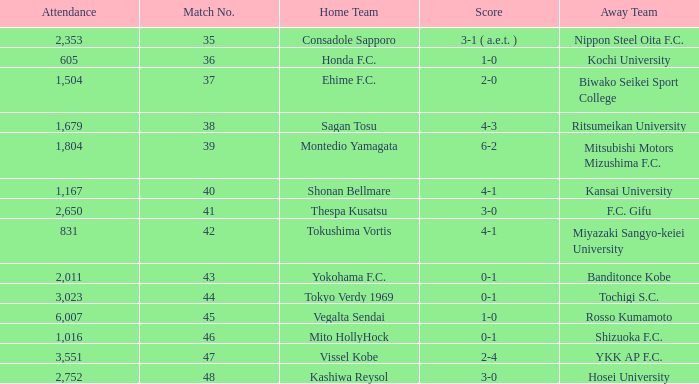After Match 43, what was the Attendance of the Match with a Score of 2-4? 3551.0. 